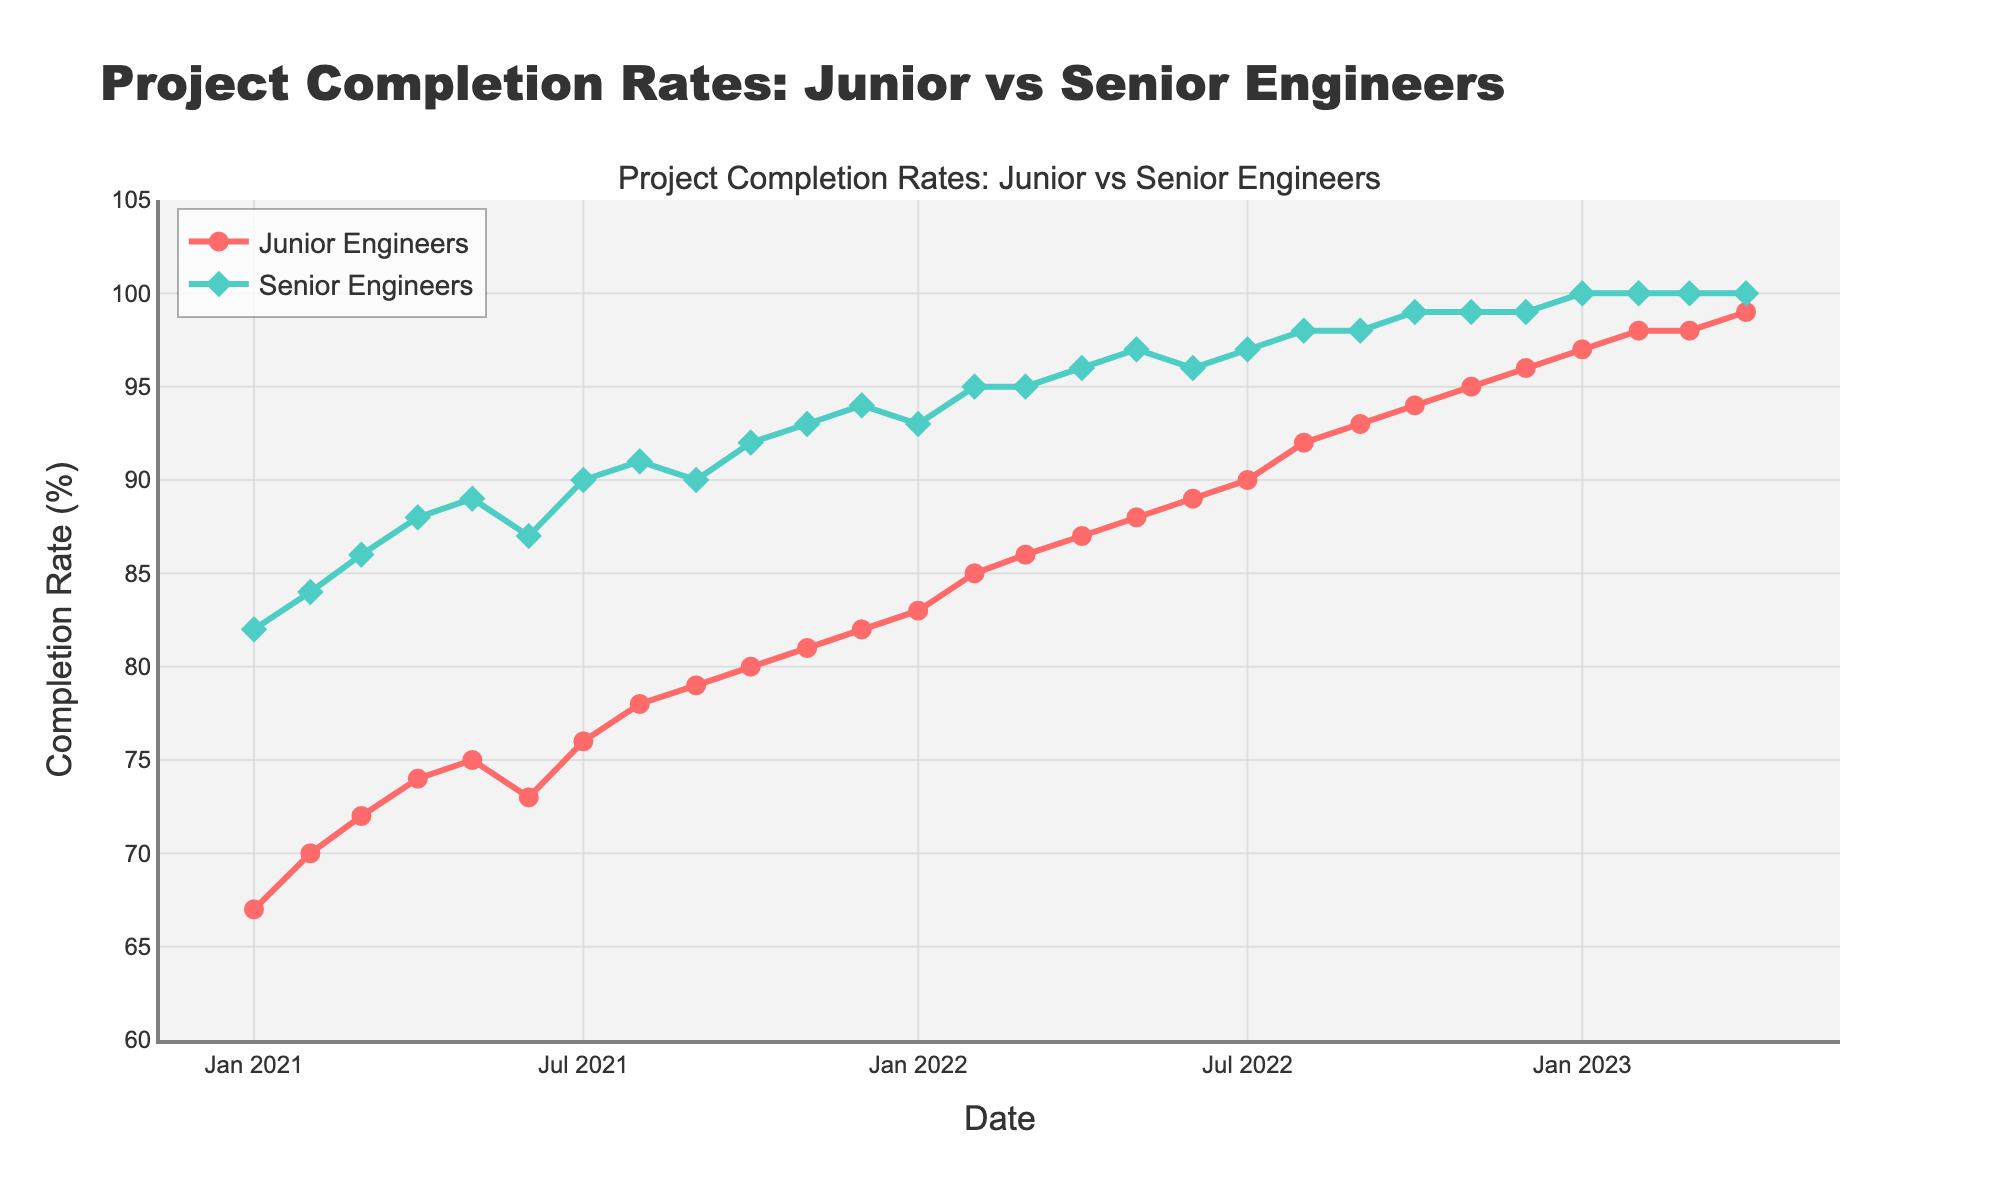What's the title of the figure? The title of the figure is located at the top center and it reads "Project Completion Rates: Junior vs Senior Engineers".
Answer: Project Completion Rates: Junior vs Senior Engineers What are the colors representing Junior and Senior Engineers? The lines and markers use different colors to distinguish between the two groups: Junior Engineers are represented by red, and Senior Engineers by green.
Answer: Junior: red, Senior: green How many data points are shown for each engineer group? The figure shows data points for each month from January 2021 to April 2023 for both Junior and Senior Engineers, giving a total of 28 data points per group.
Answer: 28 Which month and year did the Junior Engineers' completion rate reach 90% for the first time? Observing the data points on the Junior Engineers' line, we see that they first reach a 90% completion rate in July 2022.
Answer: July 2022 What is the overall trend in project completion rates for Junior Engineers from 2021 to 2023? To answer this, observe the overall movement of the Junior Engineers' line, which shows a consistent increase in completion rates over time, starting from around 67% in January 2021 to 99% in April 2023.
Answer: Increasing trend How does the completion rate of Senior Engineers in January 2021 compare with that in January 2022? Compare the data points for Senior Engineers at these two dates; it had an increase from 82% in January 2021 to 93% in January 2022.
Answer: Increased by 11% What is the difference in completion rates between Junior and Senior Engineers in January 2023? Reviewing the data points for both groups in January 2023, Junior Engineers have a 97% completion rate while Senior Engineers are at 100%. Thus, the difference is 3%.
Answer: 3% Is there any month where both Junior and Senior Engineers had the same completion rate? Scan through both lines across the timeline. There are no points where the completion rates of both Junior and Senior Engineers are the same.
Answer: No What was the percentage increase in the completion rate for Junior Engineers from January 2021 to January 2023? In January 2021, it was 67% and it increased to 97% in January 2023. The percentage increase is ((97-67)/67)*100 which is approximately 44.78%.
Answer: Approximately 44.78% Between which couple of months did Junior Engineers show the most significant change in their completion rate? By analyzing the graph and the respective slopes, the most significant increase appears between January 2022 and February 2022 (from 83% to 85%).
Answer: January 2022 to February 2022 Which group reached a 100% completion rate first, and when? Observing the data lines, Senior Engineers reached 100% first in January 2023, while Junior Engineers reached it later in April 2023.
Answer: Senior Engineers, January 2023 